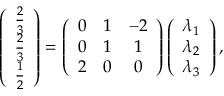<formula> <loc_0><loc_0><loc_500><loc_500>\left ( \begin{array} { c } { \frac { 2 } { 3 } } \\ { \frac { 2 } { 3 } } \\ { \frac { 1 } { 2 } } \end{array} \right ) = \left ( \begin{array} { c c c } { 0 } & { 1 } & { - 2 } \\ { 0 } & { 1 } & { 1 } \\ { 2 } & { 0 } & { 0 } \end{array} \right ) \left ( \begin{array} { c } { \lambda _ { 1 } } \\ { \lambda _ { 2 } } \\ { \lambda _ { 3 } } \end{array} \right ) ,</formula> 